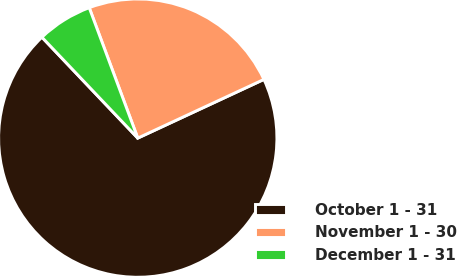Convert chart. <chart><loc_0><loc_0><loc_500><loc_500><pie_chart><fcel>October 1 - 31<fcel>November 1 - 30<fcel>December 1 - 31<nl><fcel>69.84%<fcel>23.74%<fcel>6.42%<nl></chart> 